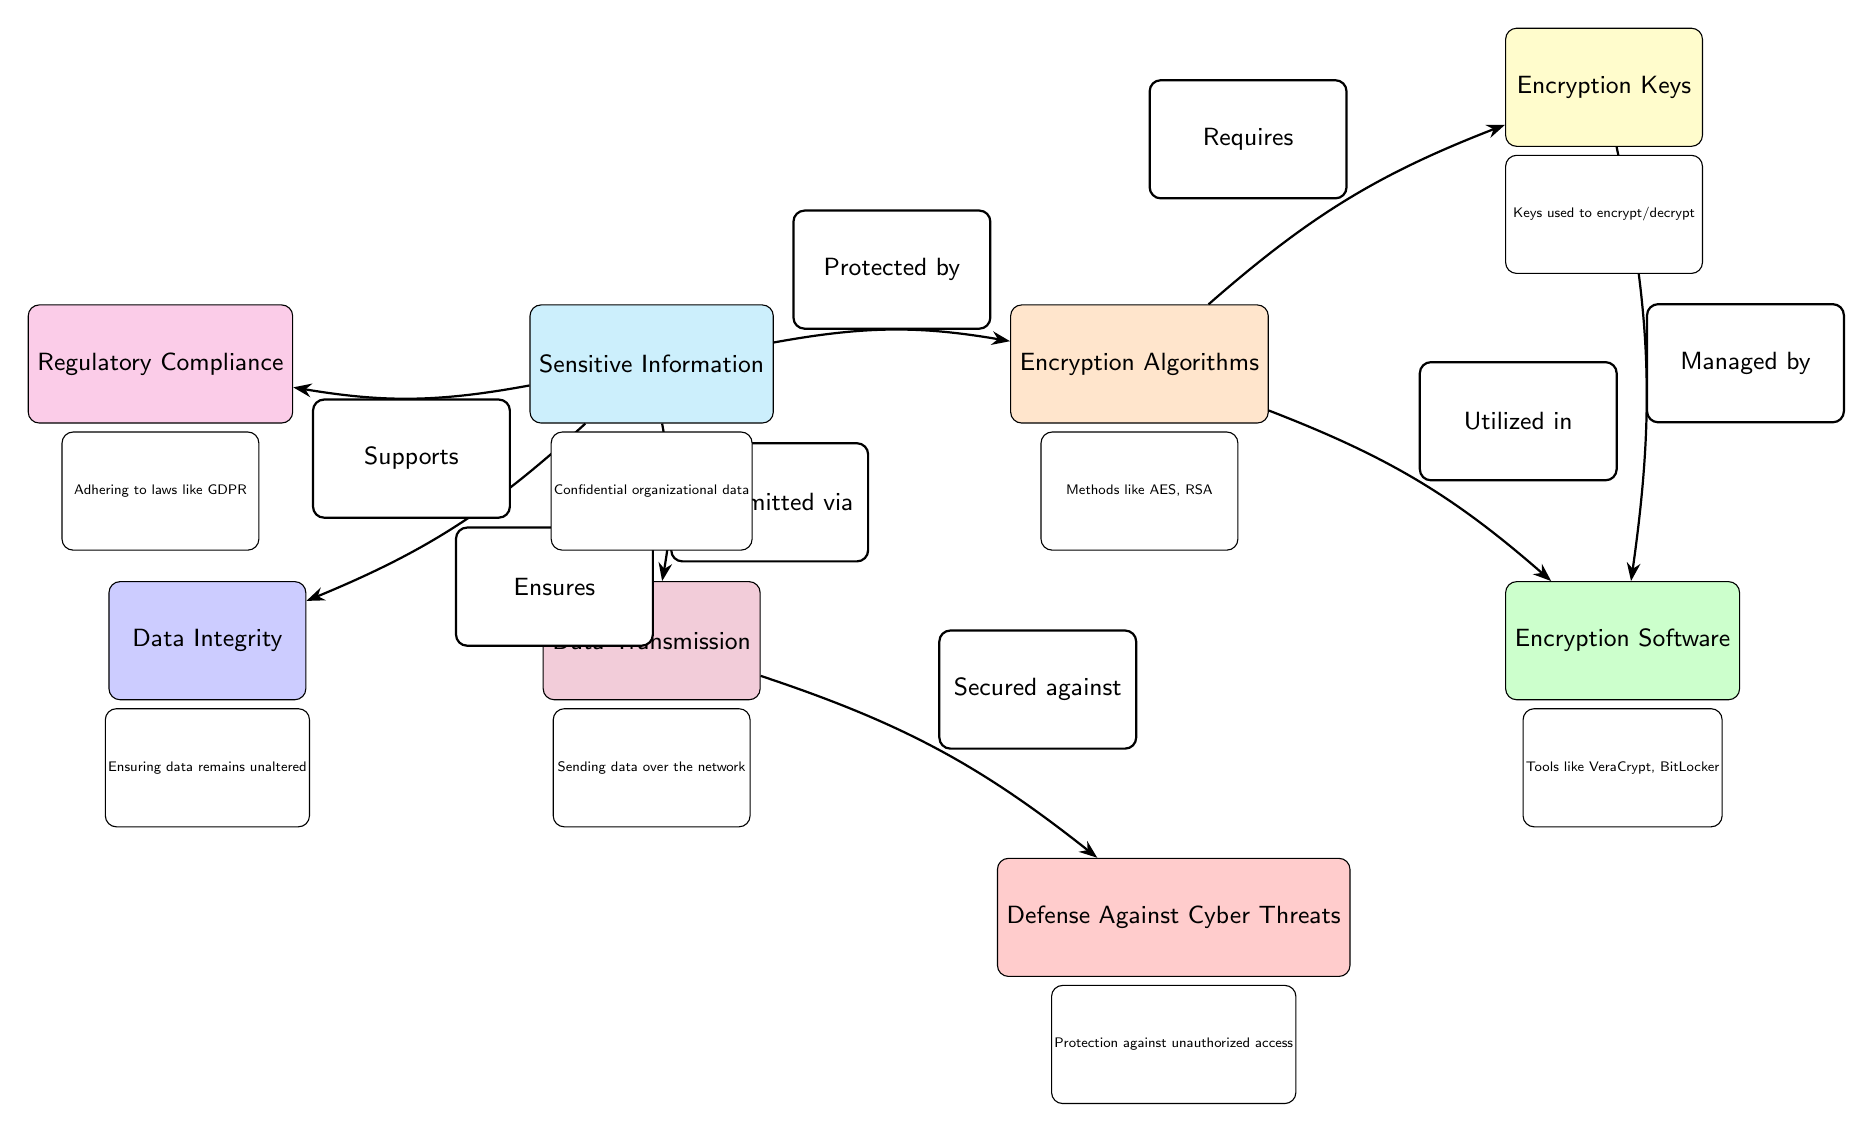What is the sensitive information protected by? The diagram indicates that the sensitive information is protected by encryption algorithms, which are specifically designed to ensure the security of confidential data.
Answer: encryption algorithms What does the encryption algorithm require? According to the diagram, encryption algorithms require encryption keys to function correctly, as these keys are essential for the encryption and decryption processes.
Answer: encryption keys What does the encryption software utilize? The diagram shows that encryption software utilizes encryption algorithms, meaning it applies these algorithms to encrypt or decrypt sensitive information.
Answer: encryption algorithms How many edges are there in the diagram? By counting the connections that connect different nodes, we find that there are a total of seven edges in the diagram.
Answer: seven What does data transmission secure against? The diagram states that data transmission is secured against defense against cyber threats, indicating a protective layer during data transfer processes.
Answer: defense against cyber threats What ensures data integrity? The diagram specifies that sensitive information ensures data integrity, which implies that it maintains the unaltered state of the data during processing and transmission.
Answer: sensitive information What regulatory compliance does sensitive information support? According to the diagram, sensitive information supports regulatory compliance with laws like GDPR, which pertains to data protection and privacy.
Answer: GDPR What is the relationship between encryption keys and encryption software? The diagram illustrates that encryption keys are managed by encryption software, indicating that the software is responsible for handling these keys during the encryption/decryption processes.
Answer: managed by How is sensitive information transmitted? As per the diagram, sensitive information is transmitted via data transmission, which indicates that these processes are interrelated for effective data handling.
Answer: data transmission 